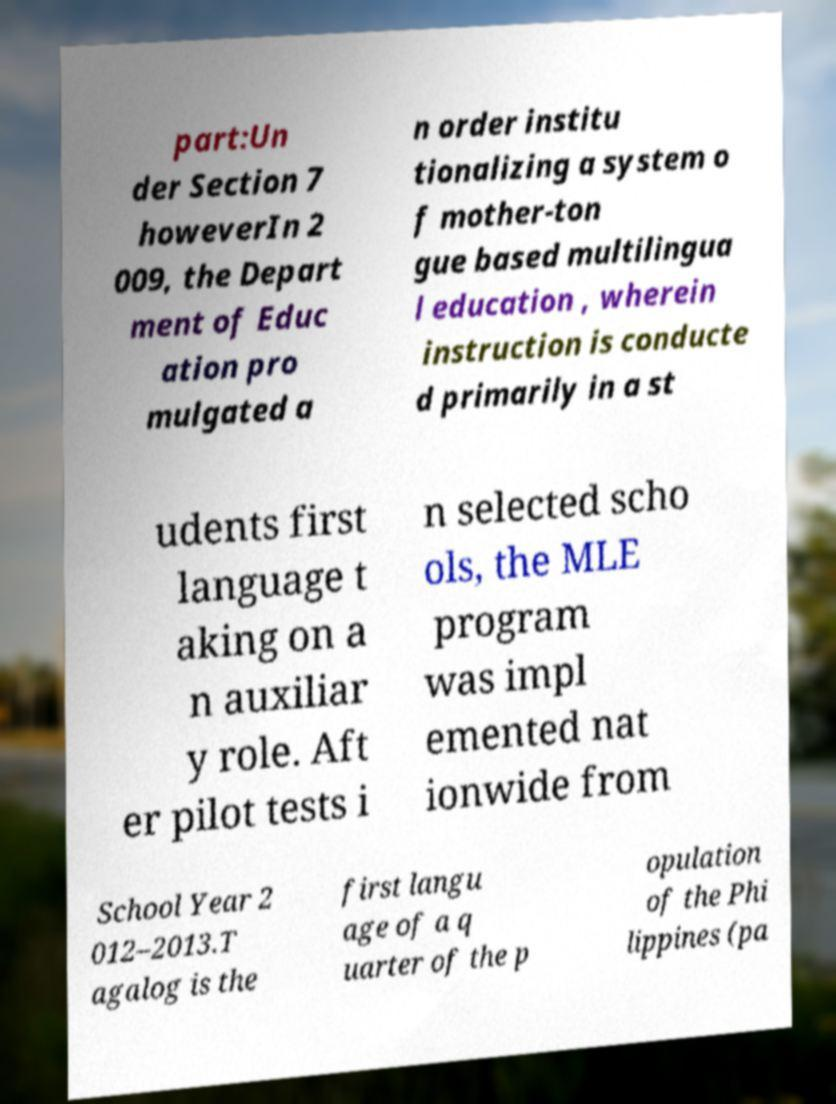Can you accurately transcribe the text from the provided image for me? part:Un der Section 7 howeverIn 2 009, the Depart ment of Educ ation pro mulgated a n order institu tionalizing a system o f mother-ton gue based multilingua l education , wherein instruction is conducte d primarily in a st udents first language t aking on a n auxiliar y role. Aft er pilot tests i n selected scho ols, the MLE program was impl emented nat ionwide from School Year 2 012–2013.T agalog is the first langu age of a q uarter of the p opulation of the Phi lippines (pa 